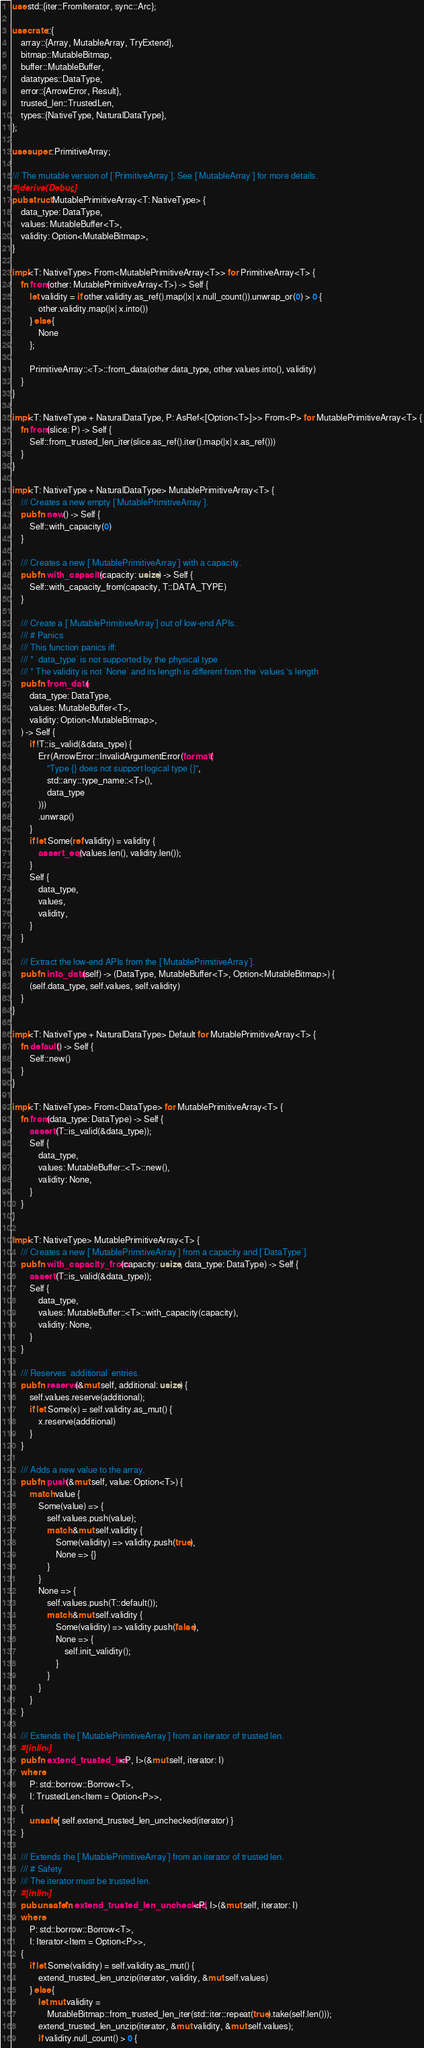<code> <loc_0><loc_0><loc_500><loc_500><_Rust_>use std::{iter::FromIterator, sync::Arc};

use crate::{
    array::{Array, MutableArray, TryExtend},
    bitmap::MutableBitmap,
    buffer::MutableBuffer,
    datatypes::DataType,
    error::{ArrowError, Result},
    trusted_len::TrustedLen,
    types::{NativeType, NaturalDataType},
};

use super::PrimitiveArray;

/// The mutable version of [`PrimitiveArray`]. See [`MutableArray`] for more details.
#[derive(Debug)]
pub struct MutablePrimitiveArray<T: NativeType> {
    data_type: DataType,
    values: MutableBuffer<T>,
    validity: Option<MutableBitmap>,
}

impl<T: NativeType> From<MutablePrimitiveArray<T>> for PrimitiveArray<T> {
    fn from(other: MutablePrimitiveArray<T>) -> Self {
        let validity = if other.validity.as_ref().map(|x| x.null_count()).unwrap_or(0) > 0 {
            other.validity.map(|x| x.into())
        } else {
            None
        };

        PrimitiveArray::<T>::from_data(other.data_type, other.values.into(), validity)
    }
}

impl<T: NativeType + NaturalDataType, P: AsRef<[Option<T>]>> From<P> for MutablePrimitiveArray<T> {
    fn from(slice: P) -> Self {
        Self::from_trusted_len_iter(slice.as_ref().iter().map(|x| x.as_ref()))
    }
}

impl<T: NativeType + NaturalDataType> MutablePrimitiveArray<T> {
    /// Creates a new empty [`MutablePrimitiveArray`].
    pub fn new() -> Self {
        Self::with_capacity(0)
    }

    /// Creates a new [`MutablePrimitiveArray`] with a capacity.
    pub fn with_capacity(capacity: usize) -> Self {
        Self::with_capacity_from(capacity, T::DATA_TYPE)
    }

    /// Create a [`MutablePrimitiveArray`] out of low-end APIs.
    /// # Panics
    /// This function panics iff:
    /// * `data_type` is not supported by the physical type
    /// * The validity is not `None` and its length is different from the `values`'s length
    pub fn from_data(
        data_type: DataType,
        values: MutableBuffer<T>,
        validity: Option<MutableBitmap>,
    ) -> Self {
        if !T::is_valid(&data_type) {
            Err(ArrowError::InvalidArgumentError(format!(
                "Type {} does not support logical type {}",
                std::any::type_name::<T>(),
                data_type
            )))
            .unwrap()
        }
        if let Some(ref validity) = validity {
            assert_eq!(values.len(), validity.len());
        }
        Self {
            data_type,
            values,
            validity,
        }
    }

    /// Extract the low-end APIs from the [`MutablePrimitiveArray`].
    pub fn into_data(self) -> (DataType, MutableBuffer<T>, Option<MutableBitmap>) {
        (self.data_type, self.values, self.validity)
    }
}

impl<T: NativeType + NaturalDataType> Default for MutablePrimitiveArray<T> {
    fn default() -> Self {
        Self::new()
    }
}

impl<T: NativeType> From<DataType> for MutablePrimitiveArray<T> {
    fn from(data_type: DataType) -> Self {
        assert!(T::is_valid(&data_type));
        Self {
            data_type,
            values: MutableBuffer::<T>::new(),
            validity: None,
        }
    }
}

impl<T: NativeType> MutablePrimitiveArray<T> {
    /// Creates a new [`MutablePrimitiveArray`] from a capacity and [`DataType`].
    pub fn with_capacity_from(capacity: usize, data_type: DataType) -> Self {
        assert!(T::is_valid(&data_type));
        Self {
            data_type,
            values: MutableBuffer::<T>::with_capacity(capacity),
            validity: None,
        }
    }

    /// Reserves `additional` entries.
    pub fn reserve(&mut self, additional: usize) {
        self.values.reserve(additional);
        if let Some(x) = self.validity.as_mut() {
            x.reserve(additional)
        }
    }

    /// Adds a new value to the array.
    pub fn push(&mut self, value: Option<T>) {
        match value {
            Some(value) => {
                self.values.push(value);
                match &mut self.validity {
                    Some(validity) => validity.push(true),
                    None => {}
                }
            }
            None => {
                self.values.push(T::default());
                match &mut self.validity {
                    Some(validity) => validity.push(false),
                    None => {
                        self.init_validity();
                    }
                }
            }
        }
    }

    /// Extends the [`MutablePrimitiveArray`] from an iterator of trusted len.
    #[inline]
    pub fn extend_trusted_len<P, I>(&mut self, iterator: I)
    where
        P: std::borrow::Borrow<T>,
        I: TrustedLen<Item = Option<P>>,
    {
        unsafe { self.extend_trusted_len_unchecked(iterator) }
    }

    /// Extends the [`MutablePrimitiveArray`] from an iterator of trusted len.
    /// # Safety
    /// The iterator must be trusted len.
    #[inline]
    pub unsafe fn extend_trusted_len_unchecked<P, I>(&mut self, iterator: I)
    where
        P: std::borrow::Borrow<T>,
        I: Iterator<Item = Option<P>>,
    {
        if let Some(validity) = self.validity.as_mut() {
            extend_trusted_len_unzip(iterator, validity, &mut self.values)
        } else {
            let mut validity =
                MutableBitmap::from_trusted_len_iter(std::iter::repeat(true).take(self.len()));
            extend_trusted_len_unzip(iterator, &mut validity, &mut self.values);
            if validity.null_count() > 0 {</code> 